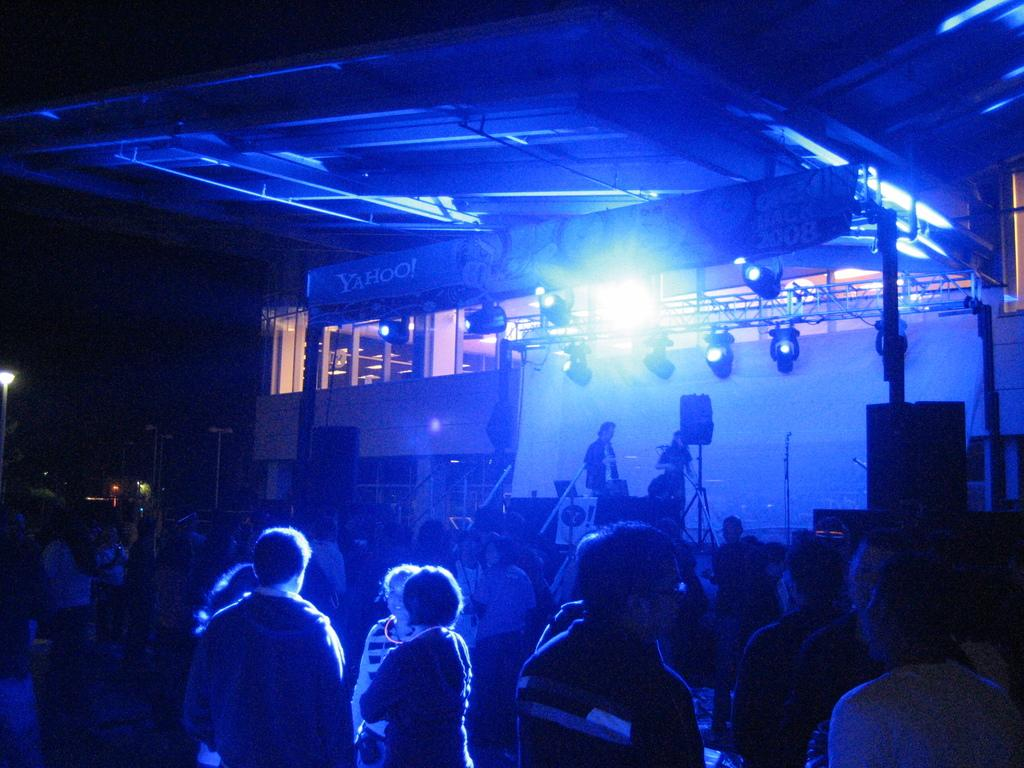How many people are in the image? There is a group of people in the image. Can you describe the location of two people in the image? Two people are on a stage in the image. What equipment is present in the image? There are speakers in the image. What can be seen providing illumination in the image? There are lights in the image. What type of signage is visible in the image? There are banners in the image. What type of structure is present in the image? There is a building in the image. What type of vertical structures are present in the image? There are poles in the image. What other objects can be seen in the image? There are some objects in the image. How would you describe the background of the image? The background of the image is dark. What type of root is visible in the image? There is no root present in the image. What type of art can be seen hanging on the walls in the image? The image does not show any art hanging on the walls. 